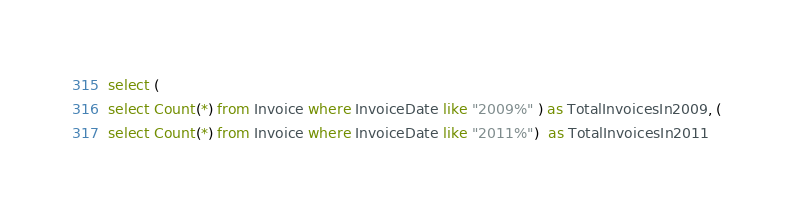<code> <loc_0><loc_0><loc_500><loc_500><_SQL_>select (
select Count(*) from Invoice where InvoiceDate like "2009%" ) as TotalInvoicesIn2009, ( 
select Count(*) from Invoice where InvoiceDate like "2011%")  as TotalInvoicesIn2011 
</code> 